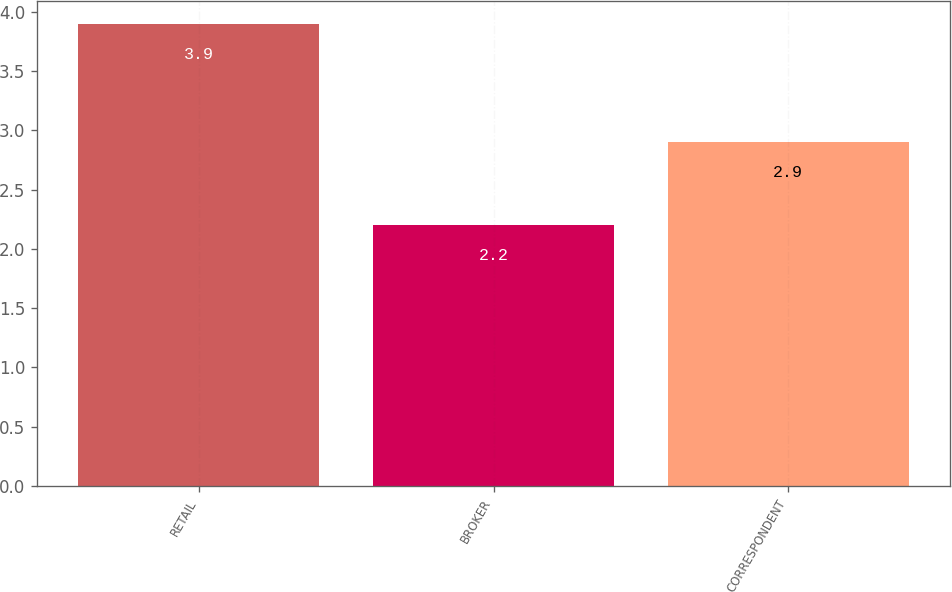Convert chart. <chart><loc_0><loc_0><loc_500><loc_500><bar_chart><fcel>RETAIL<fcel>BROKER<fcel>CORRESPONDENT<nl><fcel>3.9<fcel>2.2<fcel>2.9<nl></chart> 